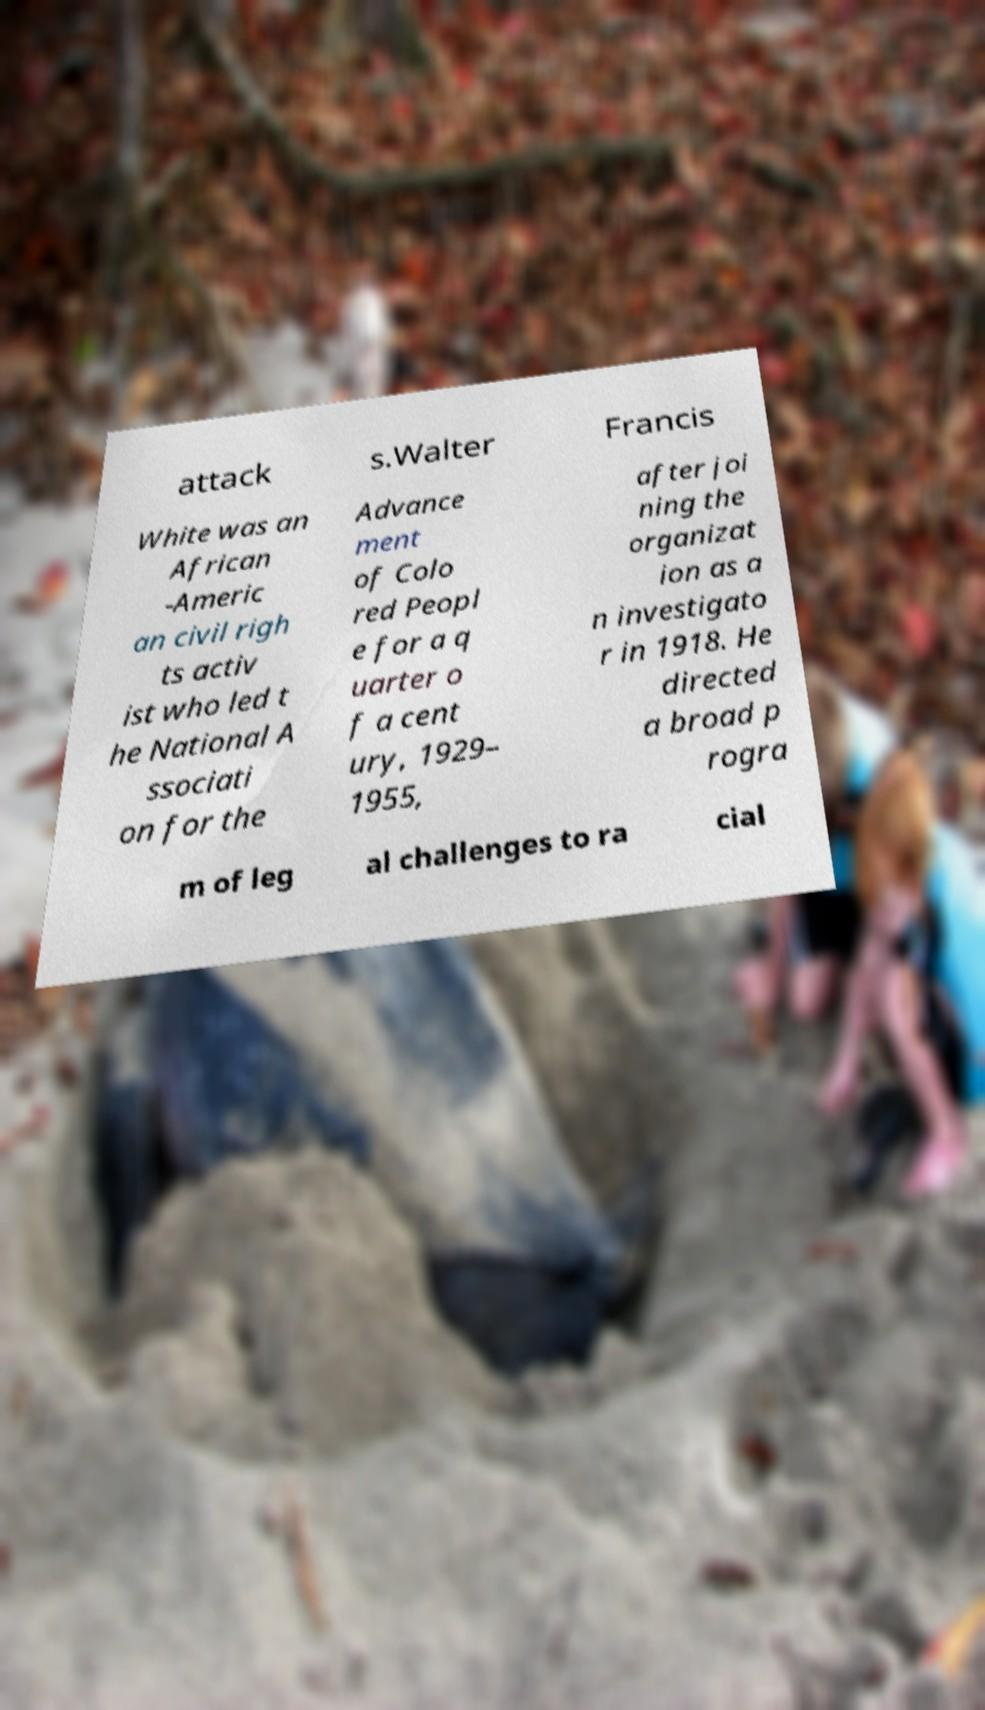What messages or text are displayed in this image? I need them in a readable, typed format. attack s.Walter Francis White was an African -Americ an civil righ ts activ ist who led t he National A ssociati on for the Advance ment of Colo red Peopl e for a q uarter o f a cent ury, 1929– 1955, after joi ning the organizat ion as a n investigato r in 1918. He directed a broad p rogra m of leg al challenges to ra cial 